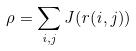Convert formula to latex. <formula><loc_0><loc_0><loc_500><loc_500>\rho = \sum _ { i , j } J ( r ( i , j ) )</formula> 